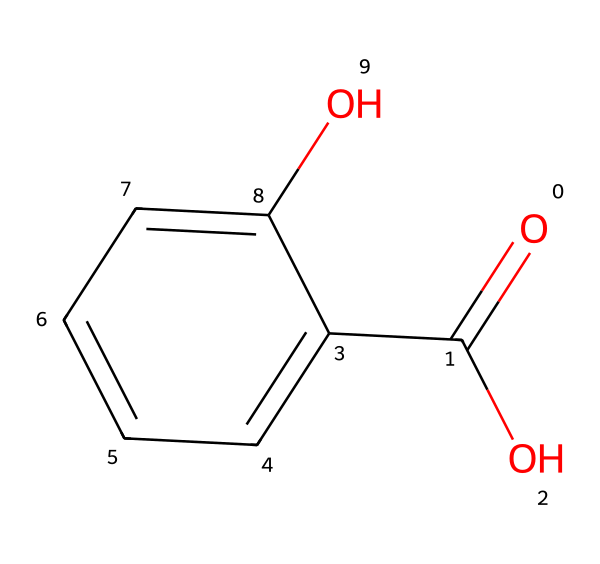How many carbon atoms are in salicylic acid? By examining the SMILES representation, we can identify the 'c' symbols, which denote carbon atoms in a ring structure, and count them. There are 7 'c' in total within the structure, indicating there are 7 carbon atoms.
Answer: 7 What type of functional group is present in salicylic acid? In the SMILES structure, the presence of ‘O=C(O)’ indicates a carboxylic acid functional group (-COOH), which includes a carbonyl (C=O) and a hydroxyl (O) group.
Answer: carboxylic acid How many hydroxyl (-OH) groups are there in salicylic acid? By inspecting the chemical structure, we can see that there is one 'O' for the hydroxyl group directly attached to the aromatic ring and one from the carboxylic group. Therefore, there are 2 hydroxyl groups in total.
Answer: 2 Is salicylic acid an aromatic compound? The presence of the cyclic 'c' atoms indicates that the compound has a benzene-like ring, which is characteristic of aromatic compounds.
Answer: yes What is the molecular formula of salicylic acid? By counting the number of each type of atom represented in the SMILES, we can derive the molecular formula: C7H6O3 (from 7 carbon, 6 hydrogen, and 3 oxygen atoms).
Answer: C7H6O3 What type of bond is found between the carbon and the oxygen in the carboxylic acid group of salicylic acid? The notation 'O=C(O)' indicates a double bond between the carbon atom and the oxygen atom in the carbonyl group (C=O), which is characteristic of carboxylic acids.
Answer: double bond What role does salicylic acid play in the synthesis of aspirin? Salicylic acid acts as a key precursor for the synthesis of aspirin through an esterification reaction with acetic anhydride or acetylsalicylic acid.
Answer: precursor 